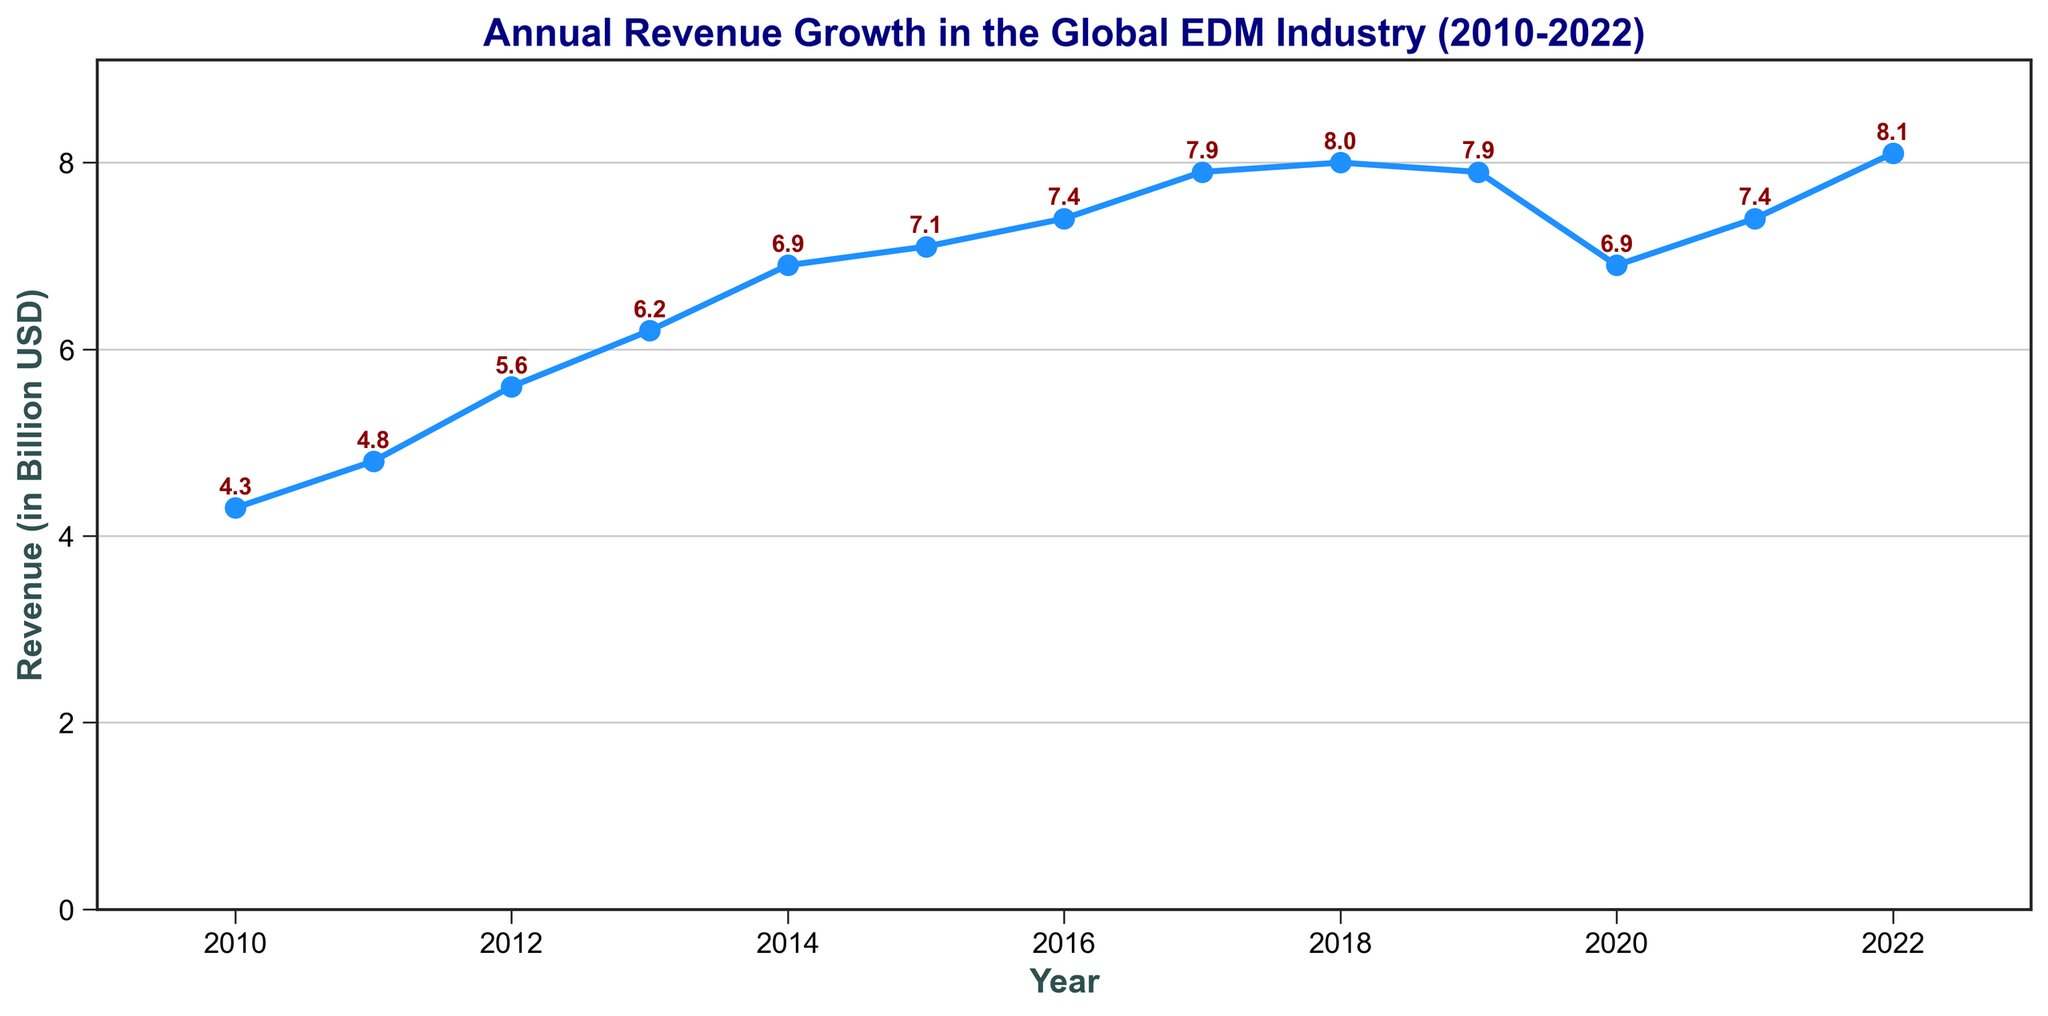What year had the highest revenue? By looking at the plot, the highest revenue is the peak point. The highest point occurs in 2022 with a value of $8.1 billion.
Answer: 2022 What was the revenue growth from 2010 to 2022? The revenue in 2010 was $4.3 billion and in 2022 it was $8.1 billion. The growth is calculated as $8.1 billion - $4.3 billion.
Answer: $3.8 billion Which year had a revenue drop compared to the previous year? By comparing each year's revenue to the previous year, the revenue drop occurs in 2019 compared to 2018 and in 2020 compared to 2019.
Answer: 2019 and 2020 What is the average revenue from 2015 to 2017? The revenues for 2015, 2016, and 2017 are $7.1 billion, $7.4 billion, and $7.9 billion respectively. Sum these values and divide by 3: ($7.1 + $7.4 + $7.9) / 3 = $22.4 / 3 = $7.47 billion.
Answer: $7.47 billion What is the difference in revenue between the year with the highest revenue and the year with the lowest revenue? The highest revenue is $8.1 billion (2022) and the lowest is $4.3 billion (2010). The difference is $8.1 billion - $4.3 billion.
Answer: $3.8 billion Which years had the same revenue? By inspecting the plot, the years 2017 and 2019 both have a revenue of $7.9 billion.
Answer: 2017 and 2019 What was the percentage drop in revenue from 2019 to 2020? The revenue in 2019 was $7.9 billion and in 2020 was $6.9 billion. The drop is calculated as (($7.9 - $6.9) / $7.9) * 100%. This equals (1 / 7.9) * 100% ≈ 12.66%.
Answer: 12.66% How many years did the revenue increase consecutively from 2010? Starting from 2010, the revenue increases consecutively until 2018. This is a total of 8 years (2011-2018 inclusive).
Answer: 8 years What is the median revenue over the given period? To find the median, sort the revenues: $4.3, $4.8, $5.6, $6.2, $6.9, $6.9, $7.1, $7.4, $7.9, $7.9, $8.0, $8.1. There are 13 values so the median is the 7th value, which is $7.1 billion.
Answer: $7.1 billion 